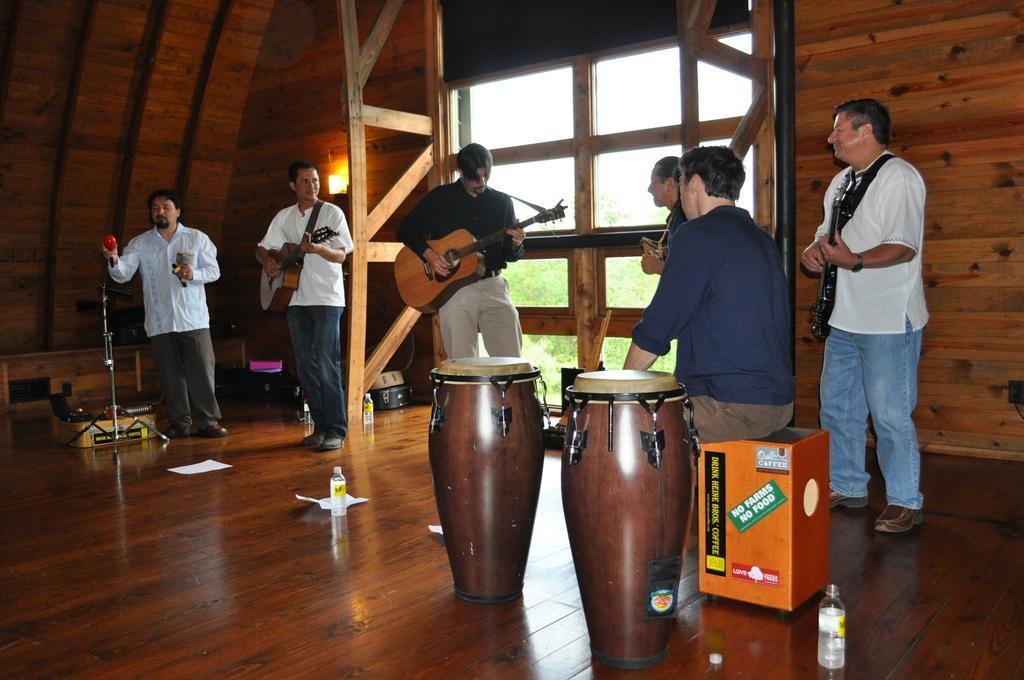How would you summarize this image in a sentence or two? In this picture we can see group of people, few people playing musical instruments and a man is seated, in front of them we can see few drums, bottles and papers, behind them we can see a light, in the background we can see few trees. 